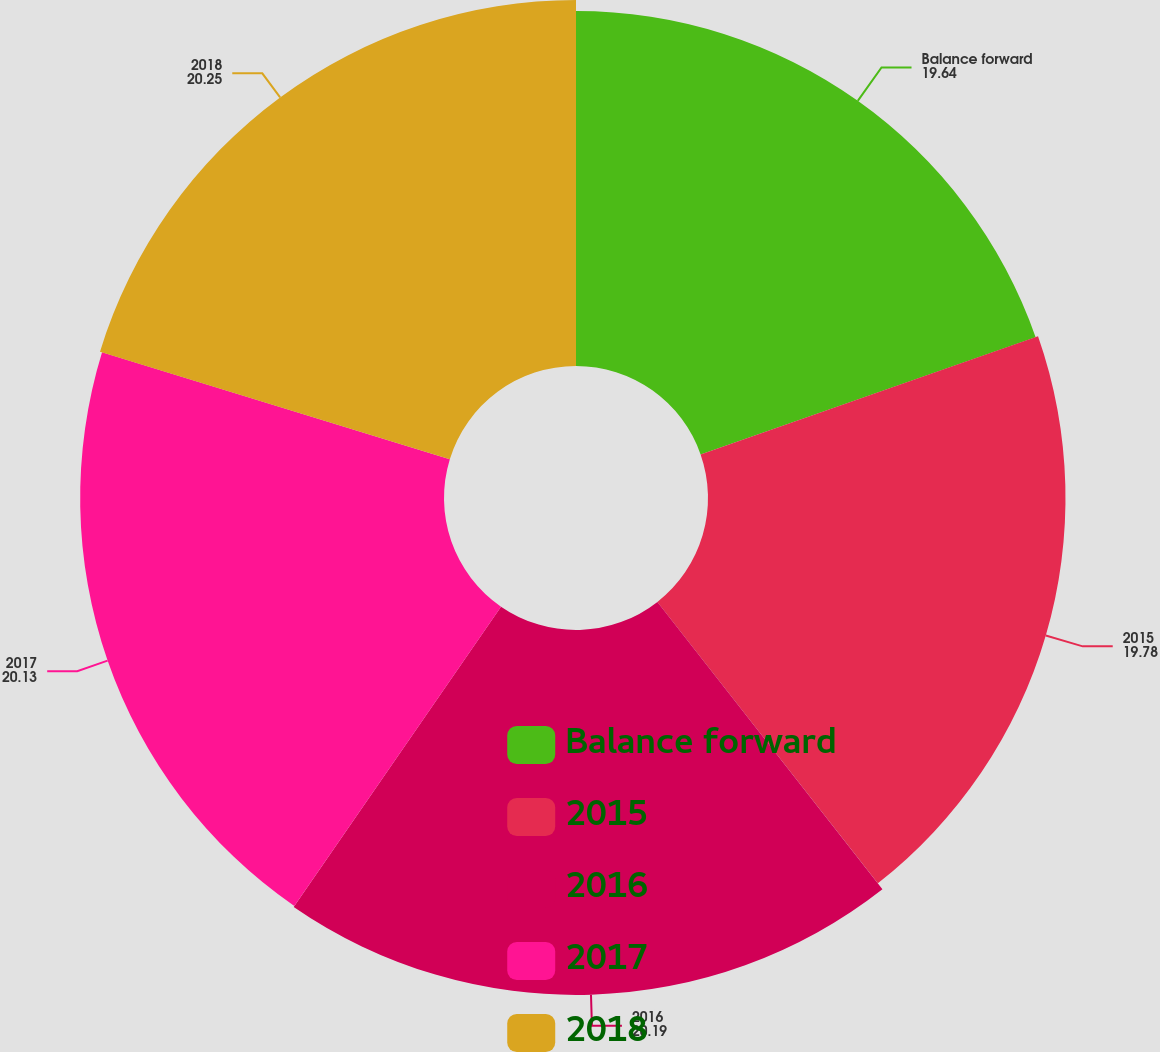Convert chart. <chart><loc_0><loc_0><loc_500><loc_500><pie_chart><fcel>Balance forward<fcel>2015<fcel>2016<fcel>2017<fcel>2018<nl><fcel>19.64%<fcel>19.78%<fcel>20.19%<fcel>20.13%<fcel>20.25%<nl></chart> 